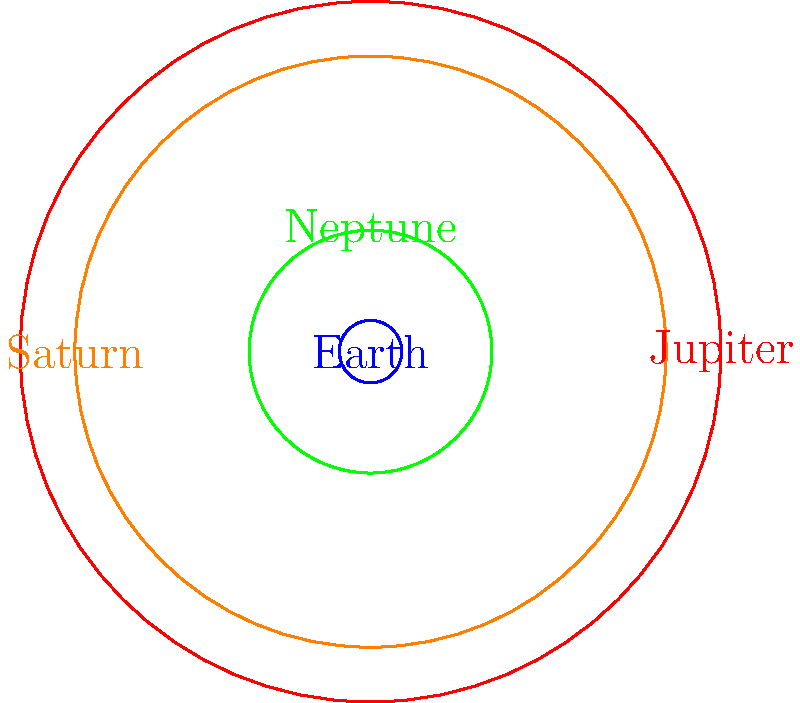In this cosmic box office, we have a stellar cast of planetary proportions! If Earth is our indie darling with a modest budget, which gas giant steals the show as the blockbuster behemoth, dwarfing its co-stars? Let's break down this celestial scene like a film critic:

1. Earth, our indie film reference point, is represented by the smallest blue circle with a radius of 1 unit.

2. Neptune, shown in green, has a radius of 3.88 times that of Earth. It's like the sleeper hit of the bunch - bigger than expected but not the main attraction.

3. Saturn, depicted in orange, boasts a radius 9.45 times larger than Earth's. It's the critically acclaimed epic with its stunning ring system, but not quite the box office champion.

4. Jupiter, illustrated in red, takes center stage with a radius 11.2 times that of Earth. It's the undisputed blockbuster of our solar system.

Comparing these celestial bodies:

$$ \text{Jupiter} > \text{Saturn} > \text{Neptune} > \text{Earth} $$

In terms of size: 11.2 > 9.45 > 3.88 > 1

Jupiter clearly outshines the competition, making it the gas giant that steals the show in this cosmic production.
Answer: Jupiter 